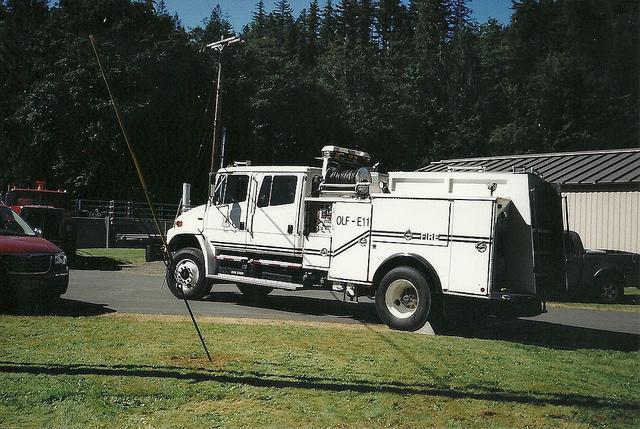How many trucks are there?
Give a very brief answer. 3. 